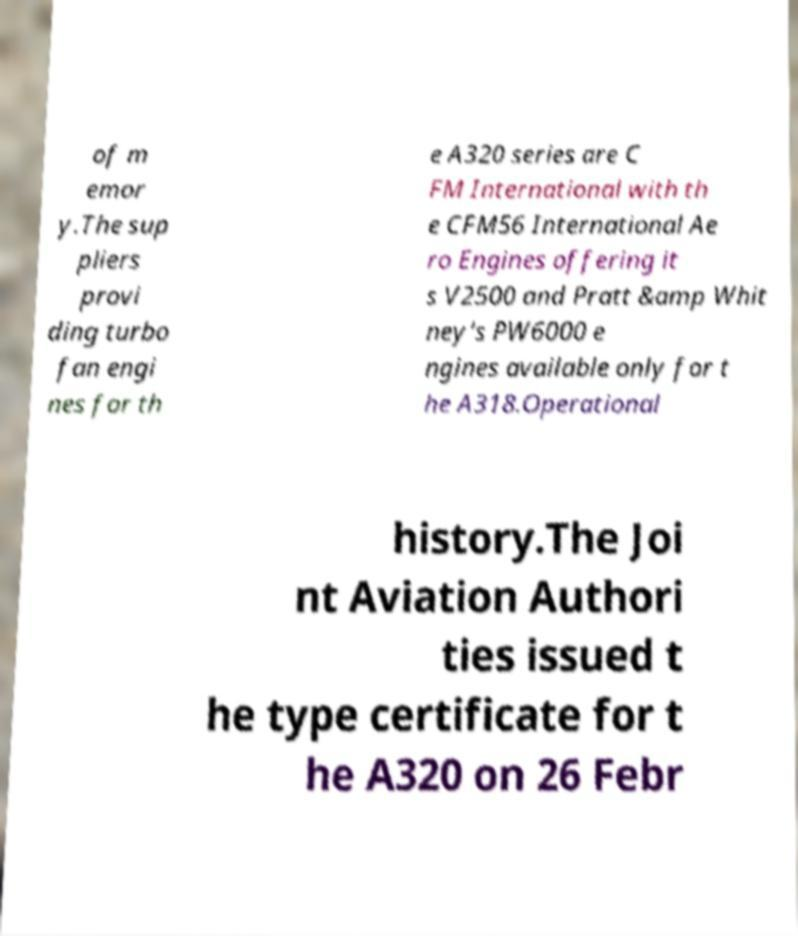Could you extract and type out the text from this image? of m emor y.The sup pliers provi ding turbo fan engi nes for th e A320 series are C FM International with th e CFM56 International Ae ro Engines offering it s V2500 and Pratt &amp Whit ney's PW6000 e ngines available only for t he A318.Operational history.The Joi nt Aviation Authori ties issued t he type certificate for t he A320 on 26 Febr 